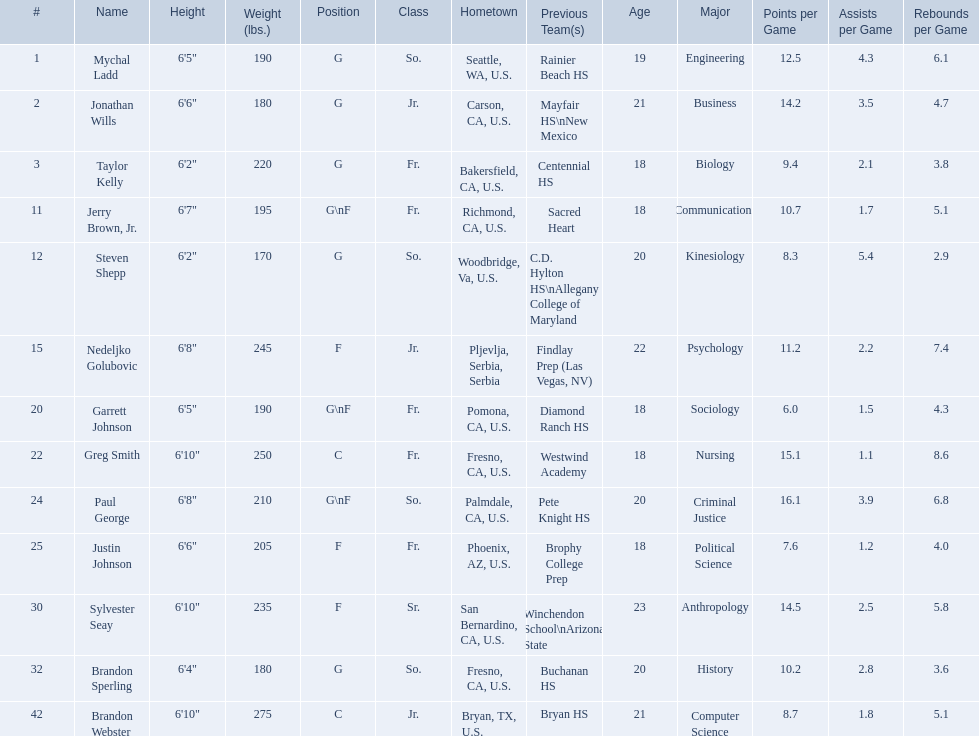Who are all of the players? Mychal Ladd, Jonathan Wills, Taylor Kelly, Jerry Brown, Jr., Steven Shepp, Nedeljko Golubovic, Garrett Johnson, Greg Smith, Paul George, Justin Johnson, Sylvester Seay, Brandon Sperling, Brandon Webster. What are their heights? 6'5", 6'6", 6'2", 6'7", 6'2", 6'8", 6'5", 6'10", 6'8", 6'6", 6'10", 6'4", 6'10". Along with taylor kelly, which other player is shorter than 6'3? Steven Shepp. 